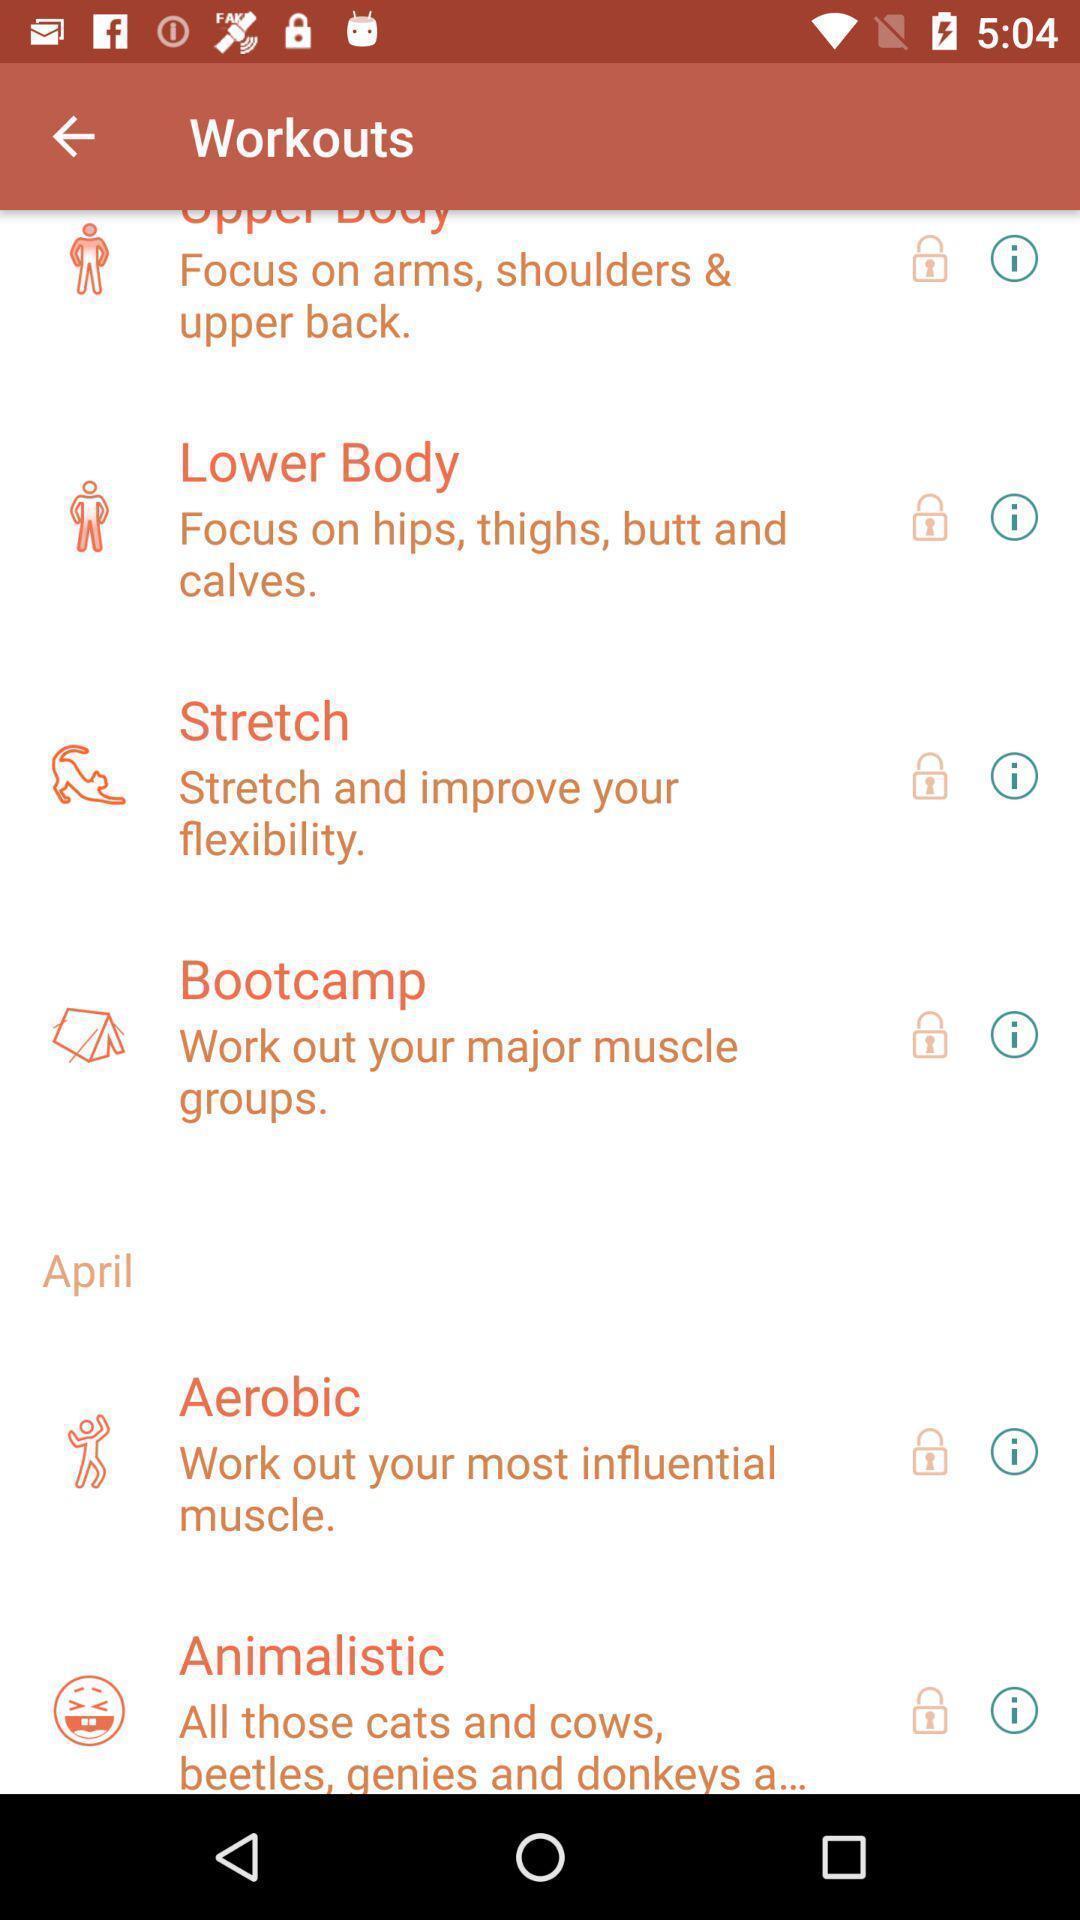What is the overall content of this screenshot? Page displaying workout list of an fitness app. 